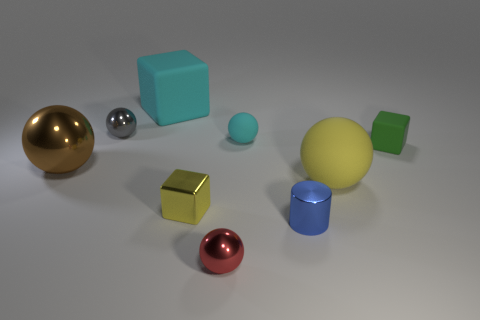Subtract all small red spheres. How many spheres are left? 4 Subtract 2 spheres. How many spheres are left? 3 Subtract all blue balls. Subtract all purple cylinders. How many balls are left? 5 Subtract all cylinders. How many objects are left? 8 Subtract all yellow blocks. Subtract all tiny yellow blocks. How many objects are left? 7 Add 3 tiny rubber things. How many tiny rubber things are left? 5 Add 4 tiny brown balls. How many tiny brown balls exist? 4 Subtract 1 blue cylinders. How many objects are left? 8 